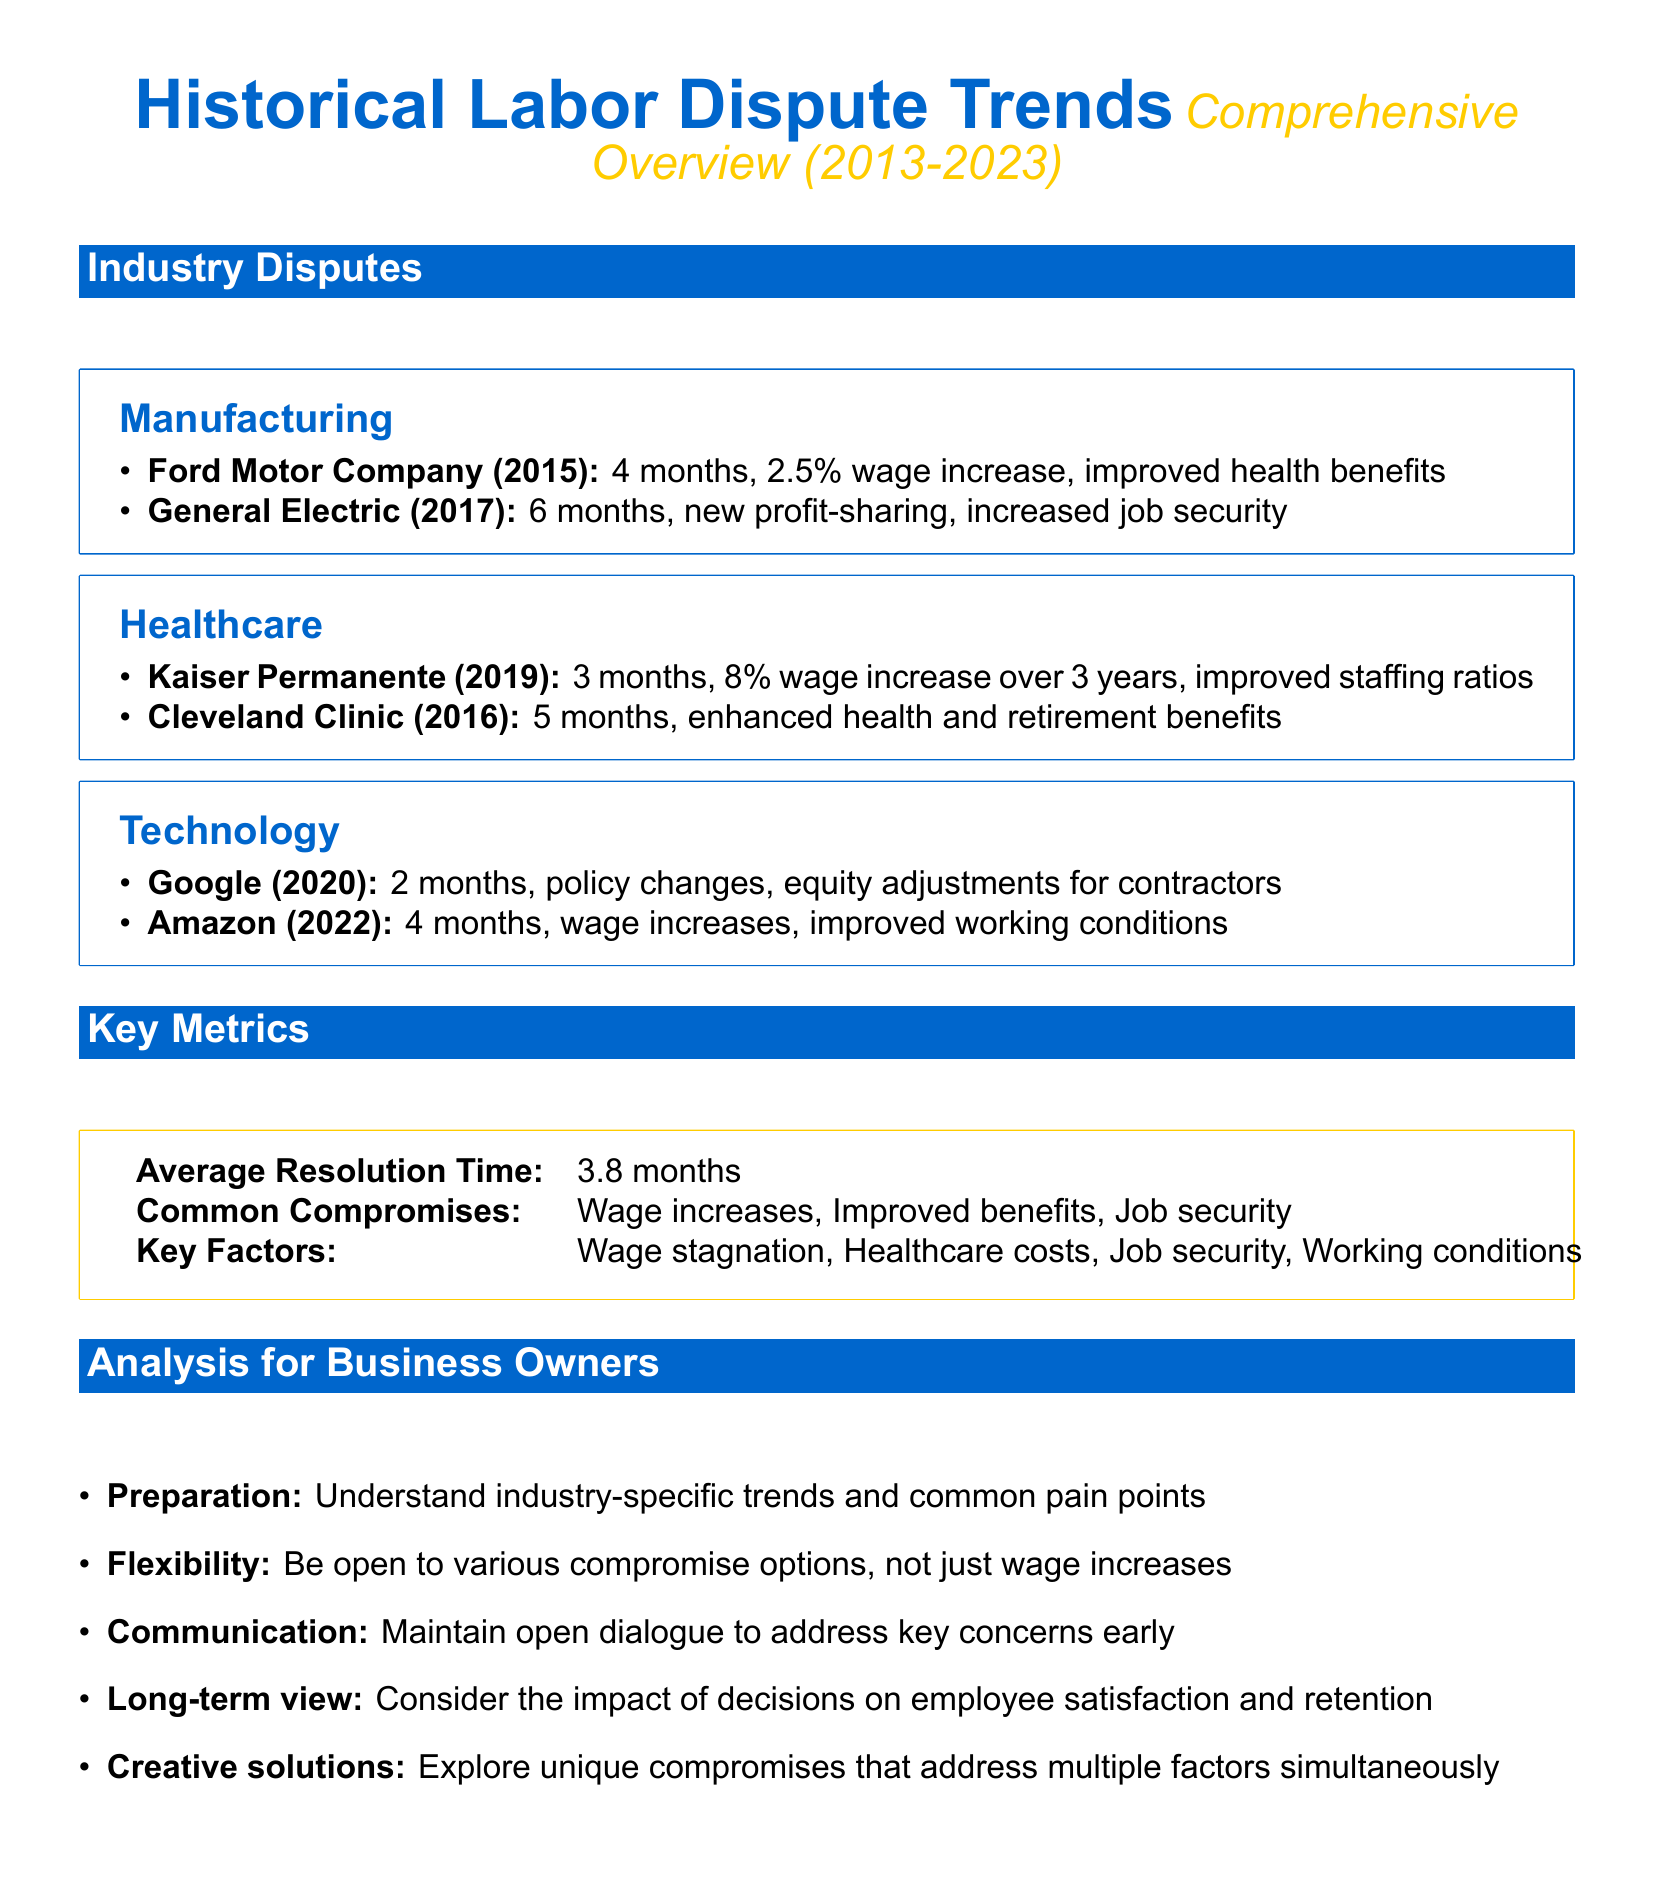What was the resolution time for Ford Motor Company? The resolution time for Ford Motor Company in 2015 was 4 months.
Answer: 4 months What was a typical compromise in the manufacturing industry? A typical compromise in the manufacturing industry includes a wage increase, as shown in the disputes listed.
Answer: Wage increase What was the average resolution time for disputes? The average resolution time for disputes over the past decade is specified as 3.8 months.
Answer: 3.8 months What key factor often drives disputes? One of the key factors driving disputes is wage stagnation, which is noted in the metrics section.
Answer: Wage stagnation Which healthcare company had a 3-month resolution time? Kaiser Permanente had a 3-month resolution time in 2019.
Answer: Kaiser Permanente What significant improvement was achieved in the General Electric dispute? The significant improvement achieved in the General Electric dispute was increased job security.
Answer: Increased job security In which year did Amazon have a labor dispute? Amazon had a labor dispute in 2022.
Answer: 2022 What was a common compromise in healthcare disputes? Enhanced health benefits were a common compromise in the healthcare industry.
Answer: Enhanced health benefits What is emphasized as important for business owners in negotiations? Communication is emphasized as important for business owners during negotiations.
Answer: Communication 